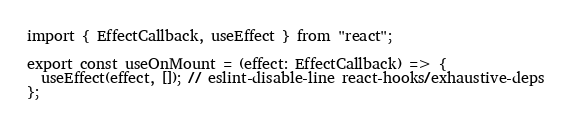Convert code to text. <code><loc_0><loc_0><loc_500><loc_500><_TypeScript_>import { EffectCallback, useEffect } from "react";

export const useOnMount = (effect: EffectCallback) => {
  useEffect(effect, []); // eslint-disable-line react-hooks/exhaustive-deps
};
</code> 